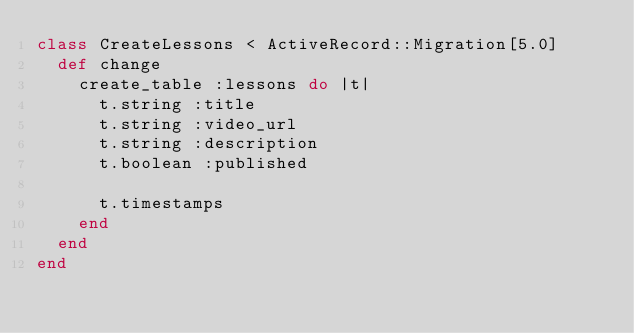<code> <loc_0><loc_0><loc_500><loc_500><_Ruby_>class CreateLessons < ActiveRecord::Migration[5.0]
  def change
    create_table :lessons do |t|
      t.string :title
      t.string :video_url
      t.string :description
      t.boolean :published

      t.timestamps
    end
  end
end
</code> 